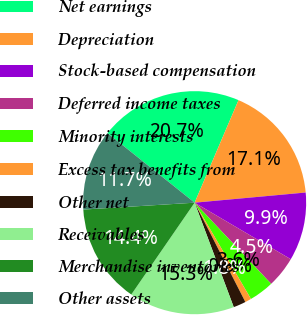Convert chart to OTSL. <chart><loc_0><loc_0><loc_500><loc_500><pie_chart><fcel>Net earnings<fcel>Depreciation<fcel>Stock-based compensation<fcel>Deferred income taxes<fcel>Minority interests<fcel>Excess tax benefits from<fcel>Other net<fcel>Receivables<fcel>Merchandise inventories<fcel>Other assets<nl><fcel>20.71%<fcel>17.11%<fcel>9.91%<fcel>4.51%<fcel>3.61%<fcel>0.91%<fcel>1.81%<fcel>15.31%<fcel>14.41%<fcel>11.71%<nl></chart> 